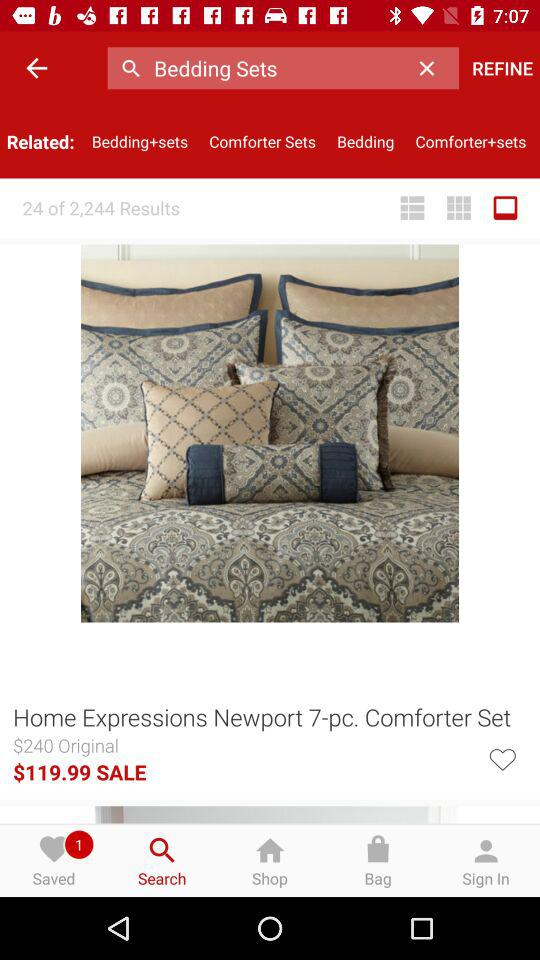What is the sale price of the comforter set? The sale price of the comforter set is $119.99. 